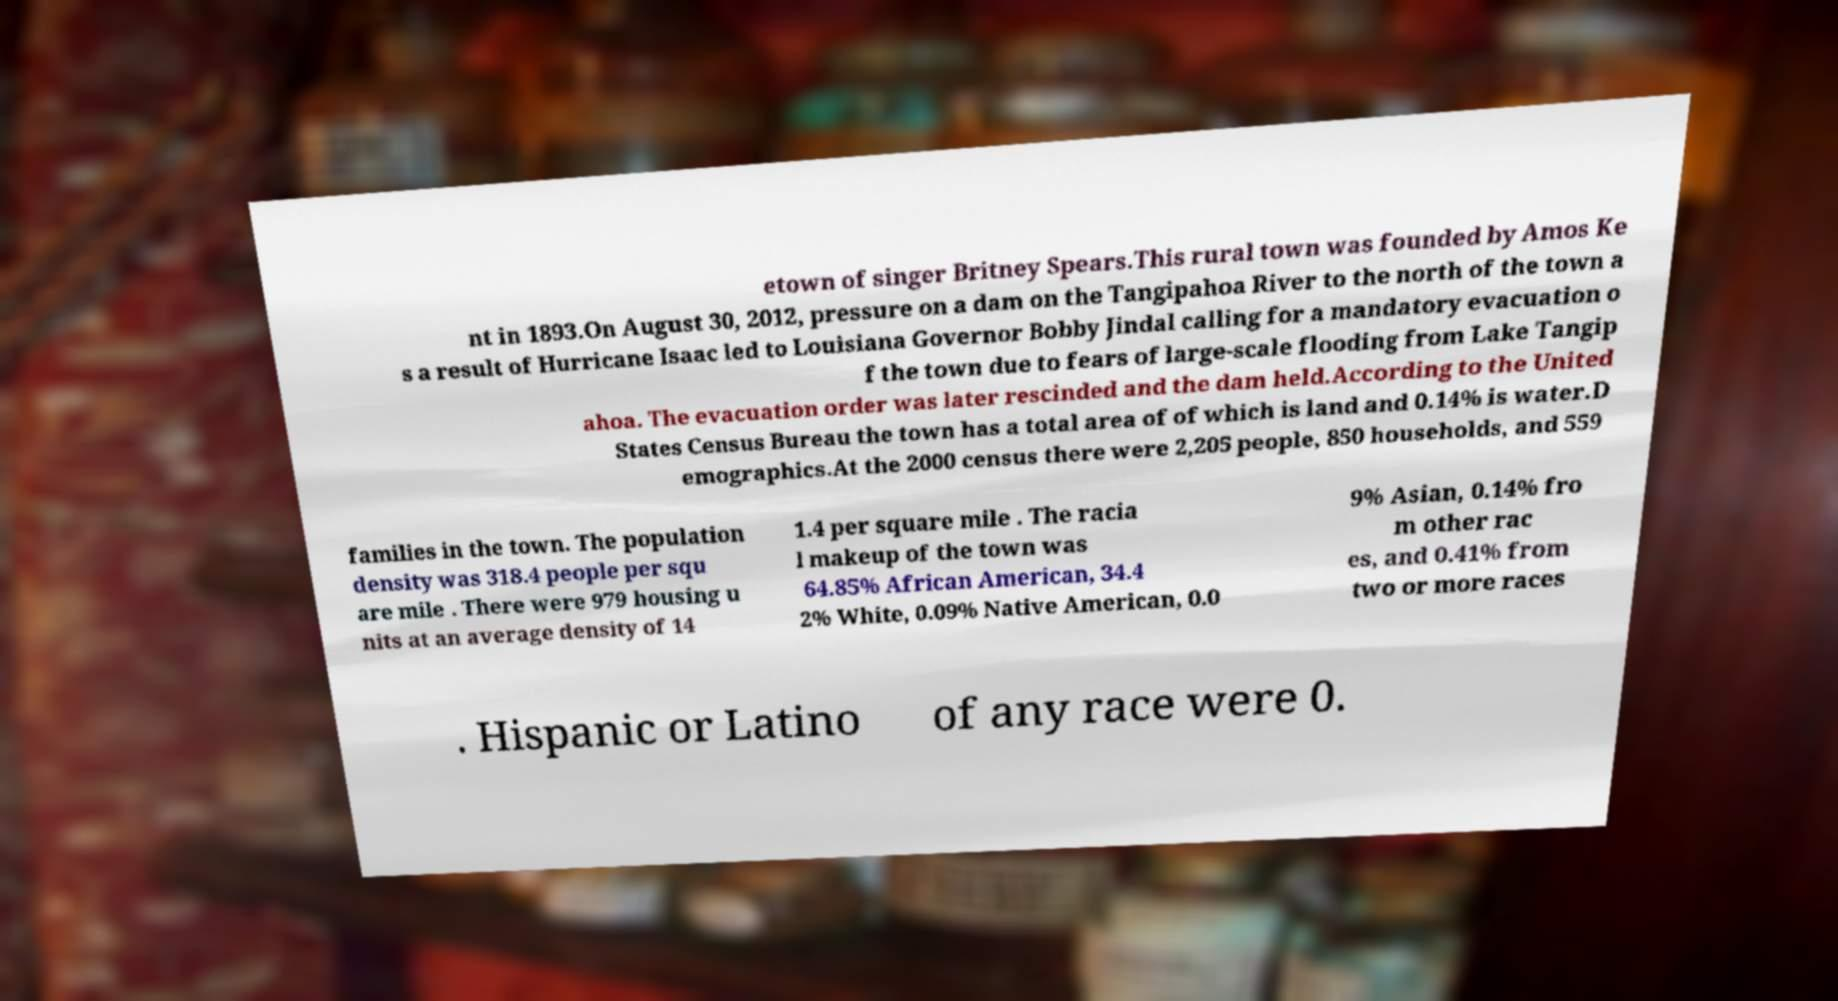I need the written content from this picture converted into text. Can you do that? etown of singer Britney Spears.This rural town was founded by Amos Ke nt in 1893.On August 30, 2012, pressure on a dam on the Tangipahoa River to the north of the town a s a result of Hurricane Isaac led to Louisiana Governor Bobby Jindal calling for a mandatory evacuation o f the town due to fears of large-scale flooding from Lake Tangip ahoa. The evacuation order was later rescinded and the dam held.According to the United States Census Bureau the town has a total area of of which is land and 0.14% is water.D emographics.At the 2000 census there were 2,205 people, 850 households, and 559 families in the town. The population density was 318.4 people per squ are mile . There were 979 housing u nits at an average density of 14 1.4 per square mile . The racia l makeup of the town was 64.85% African American, 34.4 2% White, 0.09% Native American, 0.0 9% Asian, 0.14% fro m other rac es, and 0.41% from two or more races . Hispanic or Latino of any race were 0. 